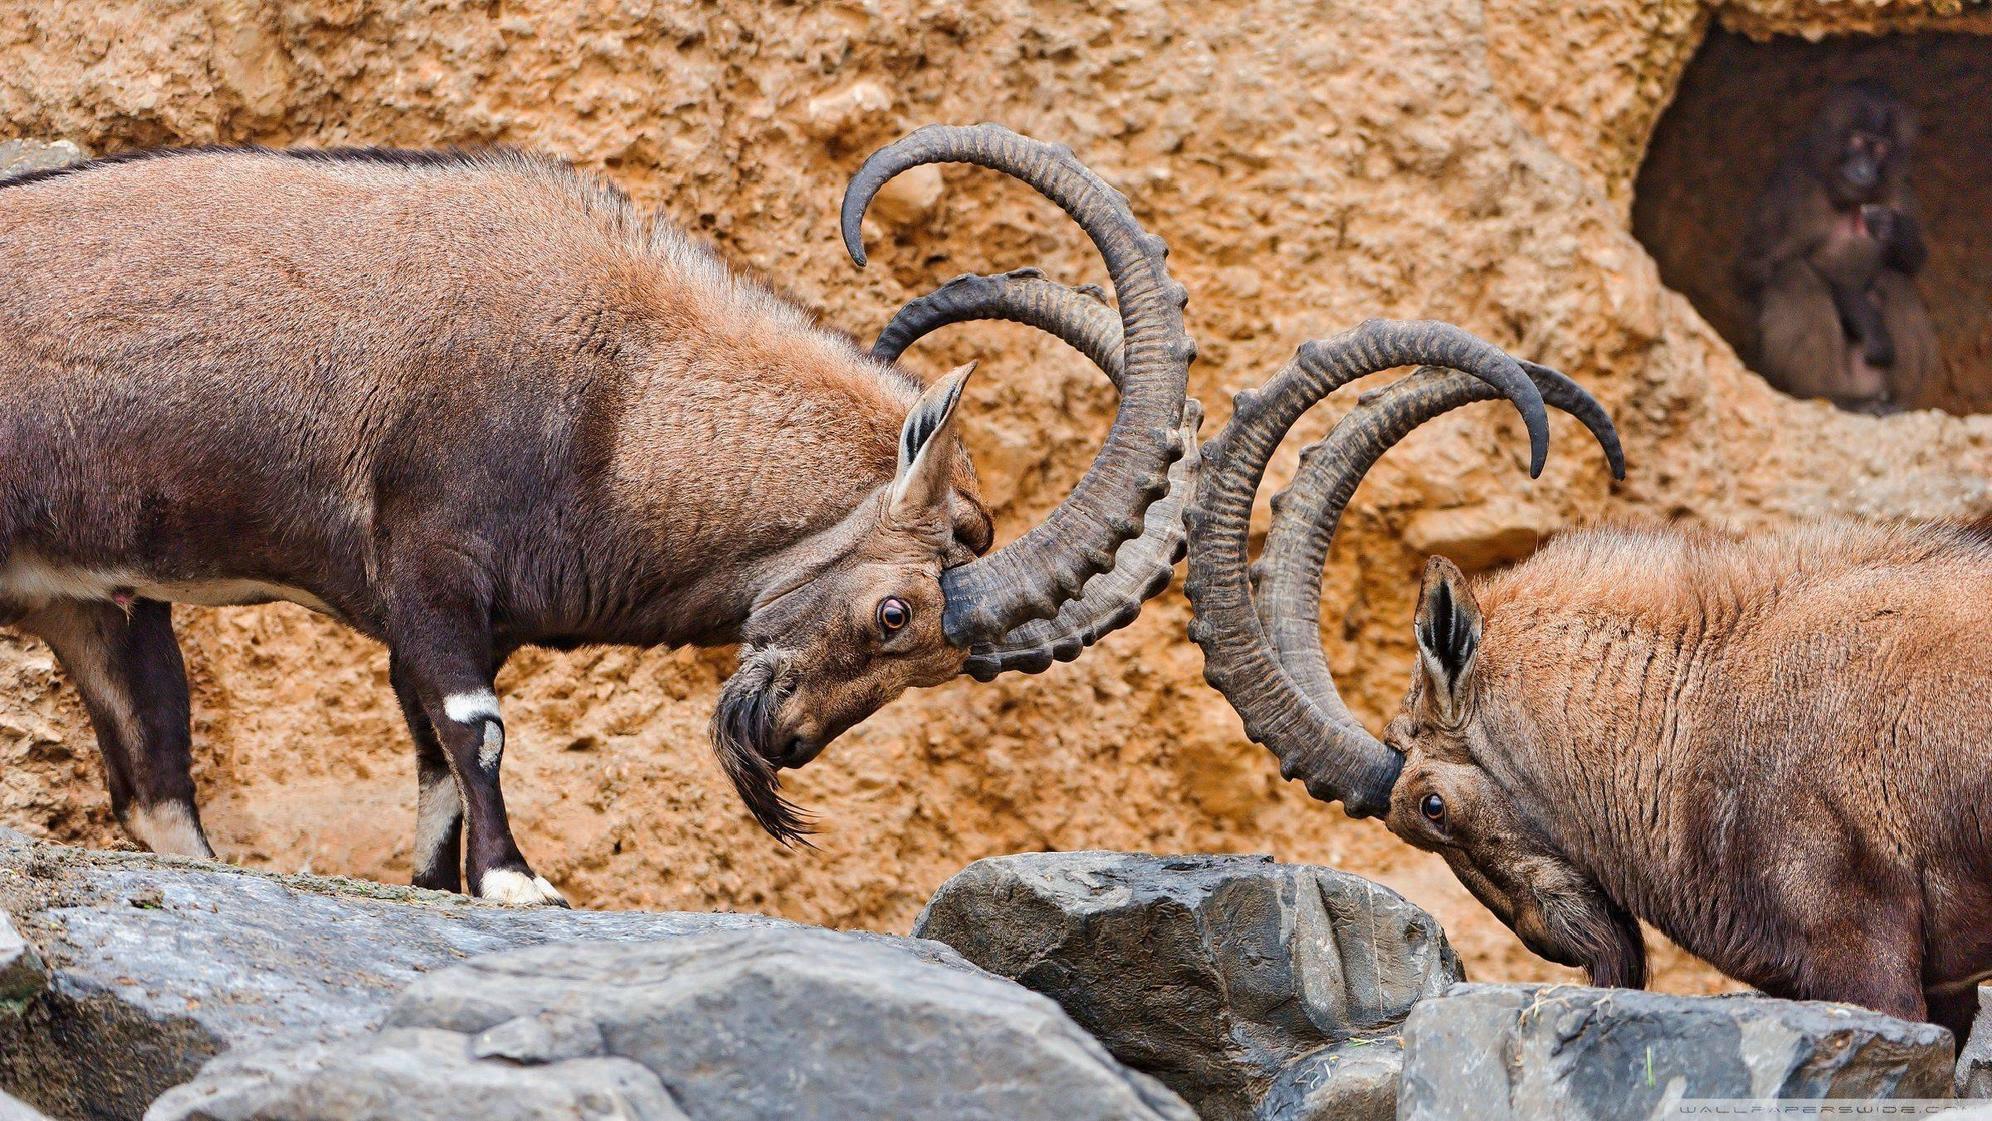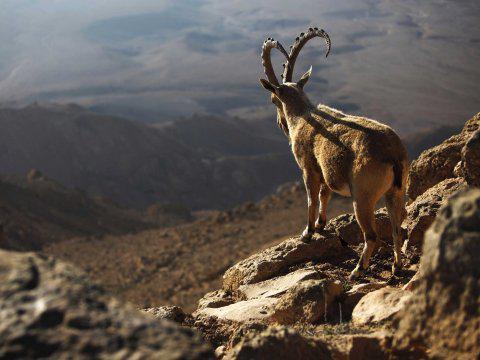The first image is the image on the left, the second image is the image on the right. For the images shown, is this caption "In one of the images of each pair two of the animals are looking at each other." true? Answer yes or no. Yes. The first image is the image on the left, the second image is the image on the right. Analyze the images presented: Is the assertion "In one image the tail of the mountain goat is visible." valid? Answer yes or no. Yes. 